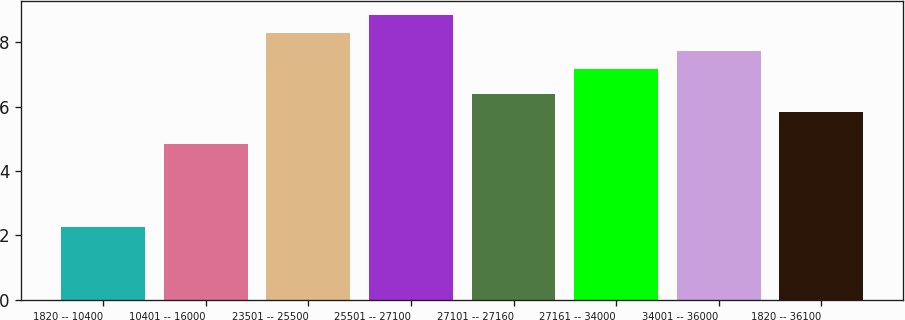Convert chart to OTSL. <chart><loc_0><loc_0><loc_500><loc_500><bar_chart><fcel>1820 -- 10400<fcel>10401 -- 16000<fcel>23501 -- 25500<fcel>25501 -- 27100<fcel>27101 -- 27160<fcel>27161 -- 34000<fcel>34001 -- 36000<fcel>1820 -- 36100<nl><fcel>2.27<fcel>4.83<fcel>8.28<fcel>8.84<fcel>6.38<fcel>7.16<fcel>7.72<fcel>5.82<nl></chart> 